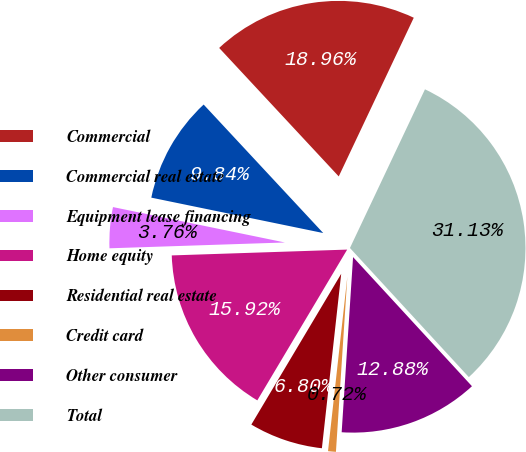Convert chart. <chart><loc_0><loc_0><loc_500><loc_500><pie_chart><fcel>Commercial<fcel>Commercial real estate<fcel>Equipment lease financing<fcel>Home equity<fcel>Residential real estate<fcel>Credit card<fcel>Other consumer<fcel>Total<nl><fcel>18.96%<fcel>9.84%<fcel>3.76%<fcel>15.92%<fcel>6.8%<fcel>0.72%<fcel>12.88%<fcel>31.13%<nl></chart> 